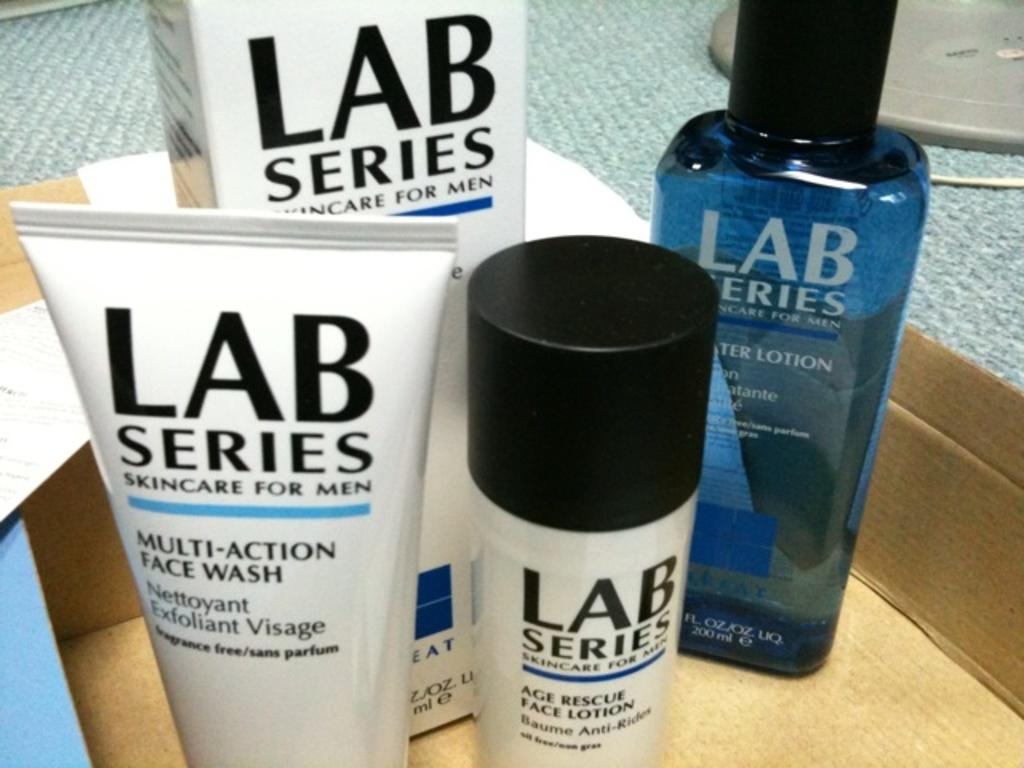What type of products are visible in the image? There is lotion and face wash in the image. How are the lotion and face wash packaged? The lotion and face wash are placed in a carton box. What is the color of the surface on which the carton box is placed? The carton box is placed on a grey surface. What type of agreement is being signed in the image? There is no indication of an agreement or signing in the image; it features lotion and face wash in a carton box on a grey surface. 